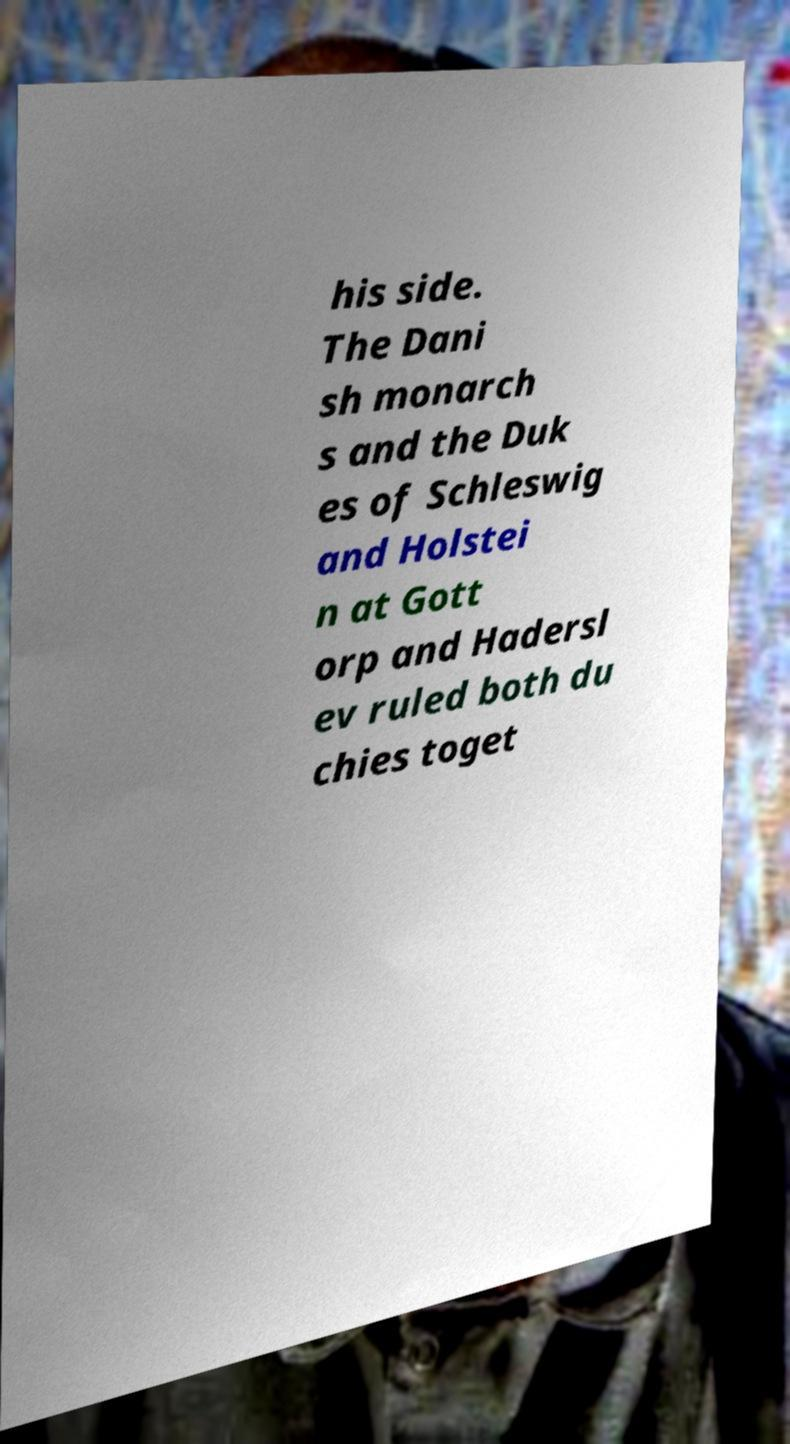Could you extract and type out the text from this image? his side. The Dani sh monarch s and the Duk es of Schleswig and Holstei n at Gott orp and Hadersl ev ruled both du chies toget 